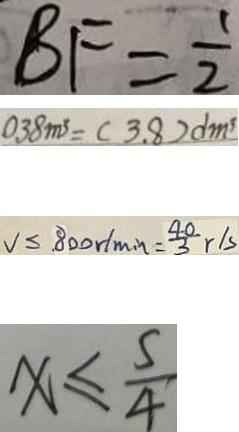<formula> <loc_0><loc_0><loc_500><loc_500>B F = \frac { 1 } { 2 } 
 0 . 3 8 m ^ { 3 } = ( 3 . 8 ) d m ^ { 3 } 
 V \leq 8 0 0 r / \min = \frac { 4 0 } { 3 } r / s 
 x \leq \frac { 5 } { 4 }</formula> 